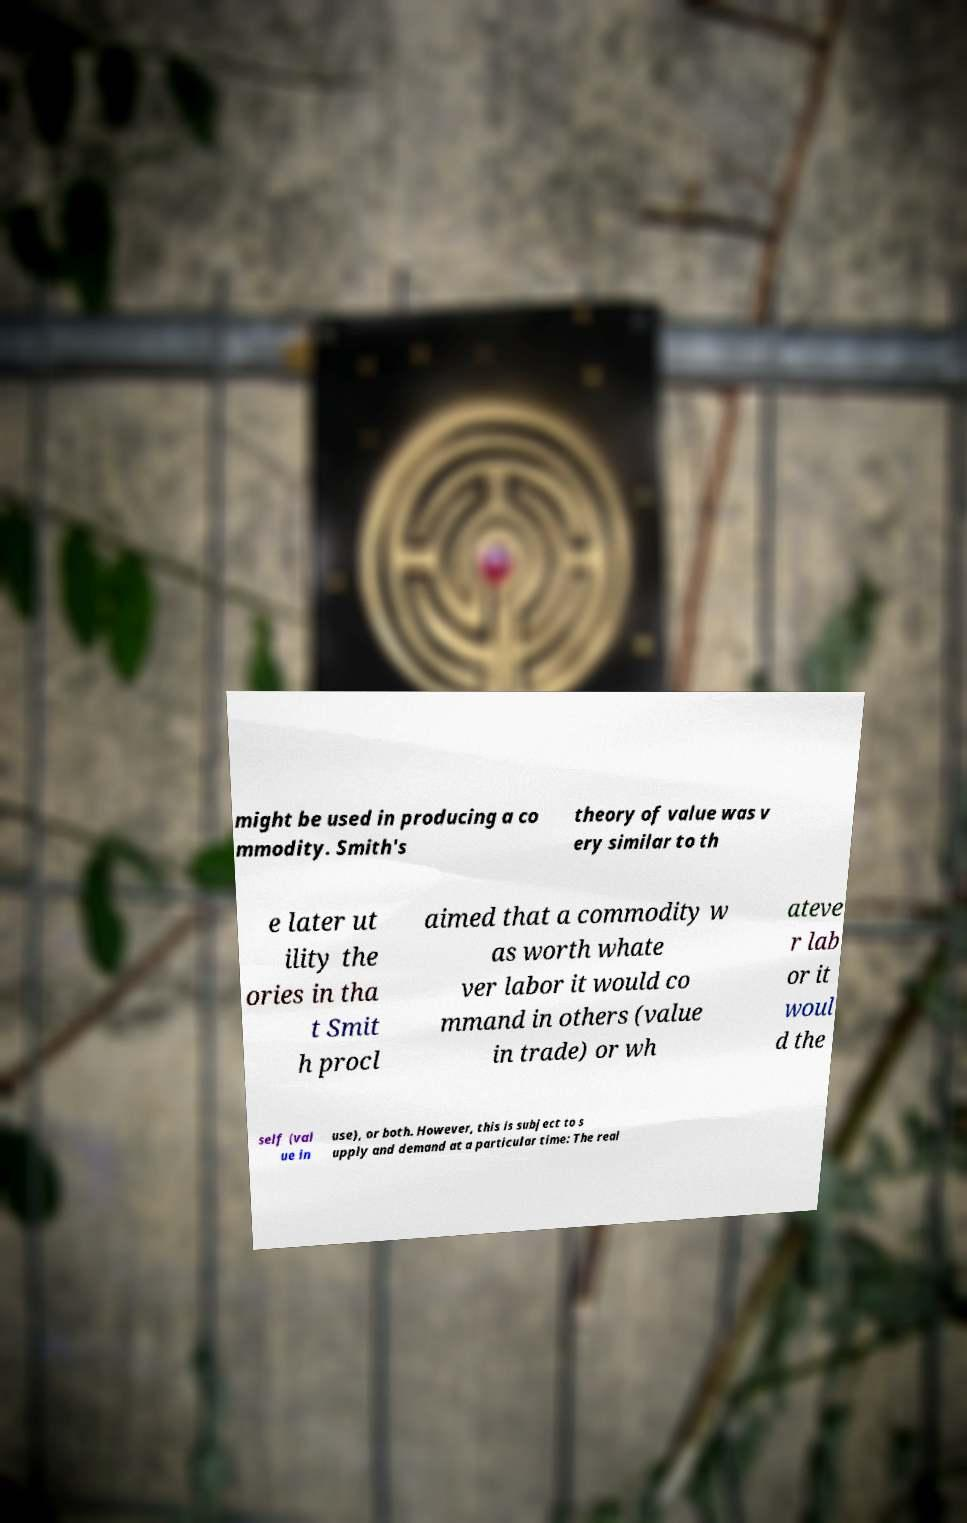Please identify and transcribe the text found in this image. might be used in producing a co mmodity. Smith's theory of value was v ery similar to th e later ut ility the ories in tha t Smit h procl aimed that a commodity w as worth whate ver labor it would co mmand in others (value in trade) or wh ateve r lab or it woul d the self (val ue in use), or both. However, this is subject to s upply and demand at a particular time: The real 